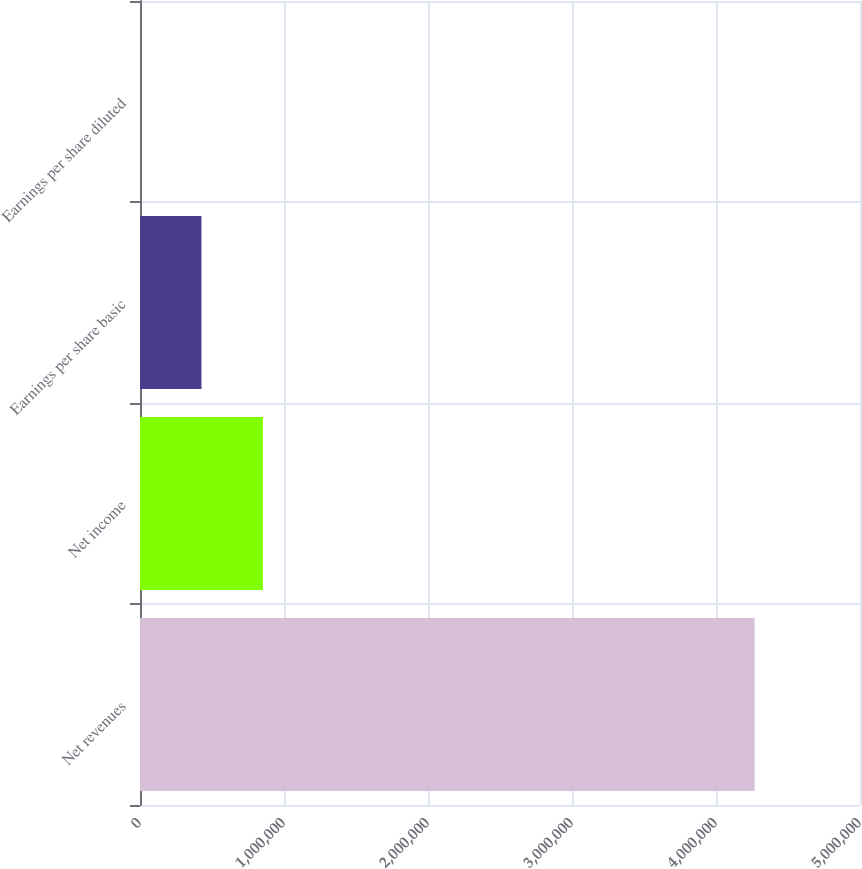Convert chart. <chart><loc_0><loc_0><loc_500><loc_500><bar_chart><fcel>Net revenues<fcel>Net income<fcel>Earnings per share basic<fcel>Earnings per share diluted<nl><fcel>4.26805e+06<fcel>853616<fcel>426811<fcel>6.41<nl></chart> 